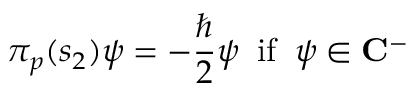Convert formula to latex. <formula><loc_0><loc_0><loc_500><loc_500>\pi _ { p } ( s _ { 2 } ) \psi = - \frac { } 2 \psi \, i f \, \psi \in { C } ^ { - }</formula> 